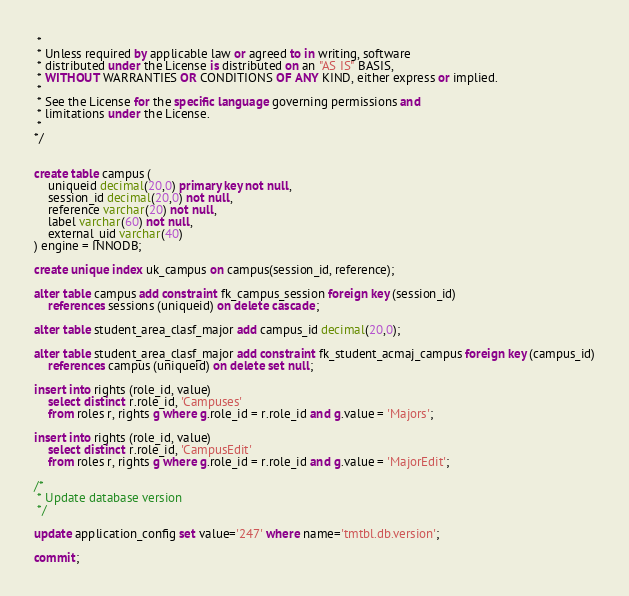Convert code to text. <code><loc_0><loc_0><loc_500><loc_500><_SQL_> *
 * Unless required by applicable law or agreed to in writing, software
 * distributed under the License is distributed on an "AS IS" BASIS,
 * WITHOUT WARRANTIES OR CONDITIONS OF ANY KIND, either express or implied.
 *
 * See the License for the specific language governing permissions and
 * limitations under the License.
 * 
*/


create table campus (
	uniqueid decimal(20,0) primary key not null,
	session_id decimal(20,0) not null,
	reference varchar(20) not null,
	label varchar(60) not null,
	external_uid varchar(40)
) engine = INNODB;

create unique index uk_campus on campus(session_id, reference);

alter table campus add constraint fk_campus_session foreign key (session_id)
	references sessions (uniqueid) on delete cascade;

alter table student_area_clasf_major add campus_id decimal(20,0);

alter table student_area_clasf_major add constraint fk_student_acmaj_campus foreign key (campus_id)
	references campus (uniqueid) on delete set null;

insert into rights (role_id, value)
	select distinct r.role_id, 'Campuses'
	from roles r, rights g where g.role_id = r.role_id and g.value = 'Majors';

insert into rights (role_id, value)
	select distinct r.role_id, 'CampusEdit'
	from roles r, rights g where g.role_id = r.role_id and g.value = 'MajorEdit';

/*
 * Update database version
 */

update application_config set value='247' where name='tmtbl.db.version';

commit;
</code> 